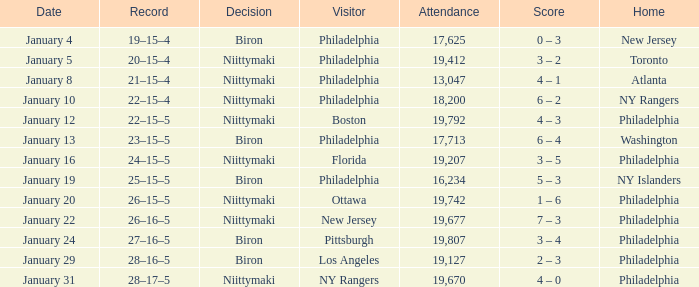Which team was the visitor on January 10? Philadelphia. 